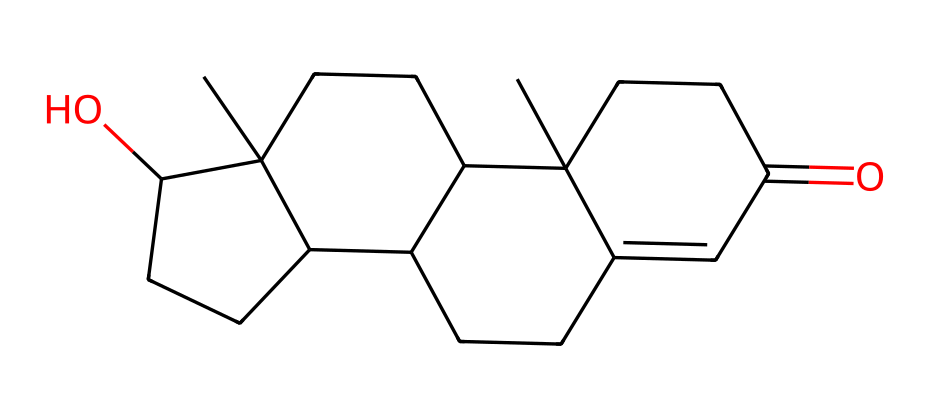What is the molecular formula of testosterone based on its structure? To determine the molecular formula from the SMILES representation, we need to count the different types of atoms present in the structure. By analyzing the SMILES, we identify 19 carbon (C) atoms, 28 hydrogen (H) atoms, and 2 oxygen (O) atoms. Putting these together, the molecular formula is C19H28O2.
Answer: C19H28O2 How many rings are present in the structure of testosterone? The rings in the chemical structure can be identified by looking for the numbers in the SMILES notation, which indicate where rings close. In this case, the numbers 1, 2, 3, and 4 denote four ring closures. Thus, there are four rings present in the structure.
Answer: 4 What is the significance of the hydroxyl (OH) group in this chemical? The hydroxyl group (-OH) is important in testosterone's structure as it enhances solubility and plays a role in its biological activity. This functional group is associated with steroid hormones, affecting their binding to receptors. Therefore, the presence of the hydroxyl group indicates that it can have distinct physiological effects.
Answer: solubility What characteristic of testosterone allows it to pass through cell membranes? Testosterone is a lipophilic (fat-soluble) molecule due to its steroid structure, which consists of multiple carbon rings. This lipophilicity enables it to easily diffuse through lipid bilayers of cell membranes. The non-polar nature of testosterone facilitates its entry into target cells.
Answer: lipophilicity How many oxygen atoms are present in the testosterone molecule? From the SMILES notation, we can directly see the presence of two instances of the letter 'O', indicating that there are two oxygen atoms in the chemical structure of testosterone.
Answer: 2 What type of lipid does testosterone belong to? Testosterone belongs to the class of lipids known as steroids, characterized by their four-ring carbon structure. The presence of the rings and the specific functional groups define its classification clearly as a steroid lipid.
Answer: steroids What role do steroids like testosterone play in athletic performance? Steroids like testosterone are known to promote muscle growth, increase strength, and enhance recovery, which can lead to improved athletic performance. They affect protein synthesis and influence various physiological processes related to physical exertion.
Answer: enhance performance 